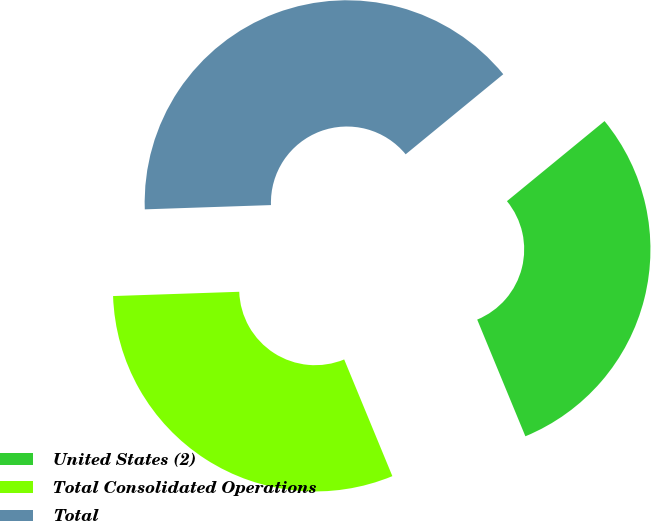<chart> <loc_0><loc_0><loc_500><loc_500><pie_chart><fcel>United States (2)<fcel>Total Consolidated Operations<fcel>Total<nl><fcel>29.7%<fcel>30.69%<fcel>39.6%<nl></chart> 